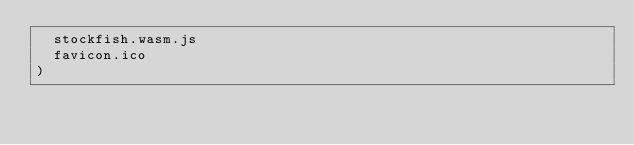<code> <loc_0><loc_0><loc_500><loc_500><_Ruby_>  stockfish.wasm.js
  favicon.ico
)
</code> 